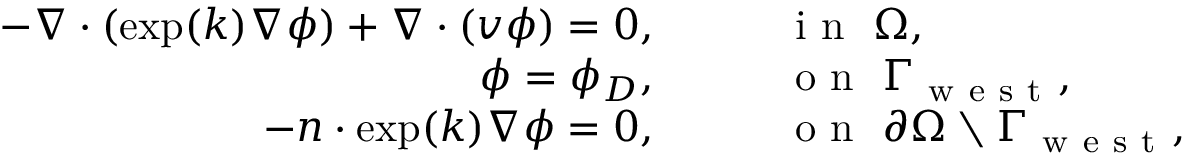<formula> <loc_0><loc_0><loc_500><loc_500>\begin{array} { r l } { - \nabla \cdot ( \exp ( k ) \nabla \phi ) + \nabla \cdot ( v \phi ) = 0 , } & \quad i n \ \Omega , } \\ { \phi = \phi _ { D } , } & \quad o n \ \Gamma _ { w e s t } , } \\ { - n \cdot \exp ( k ) \nabla \phi = 0 , } & \quad o n \ \partial \Omega \ \Gamma _ { w e s t } , } \end{array}</formula> 